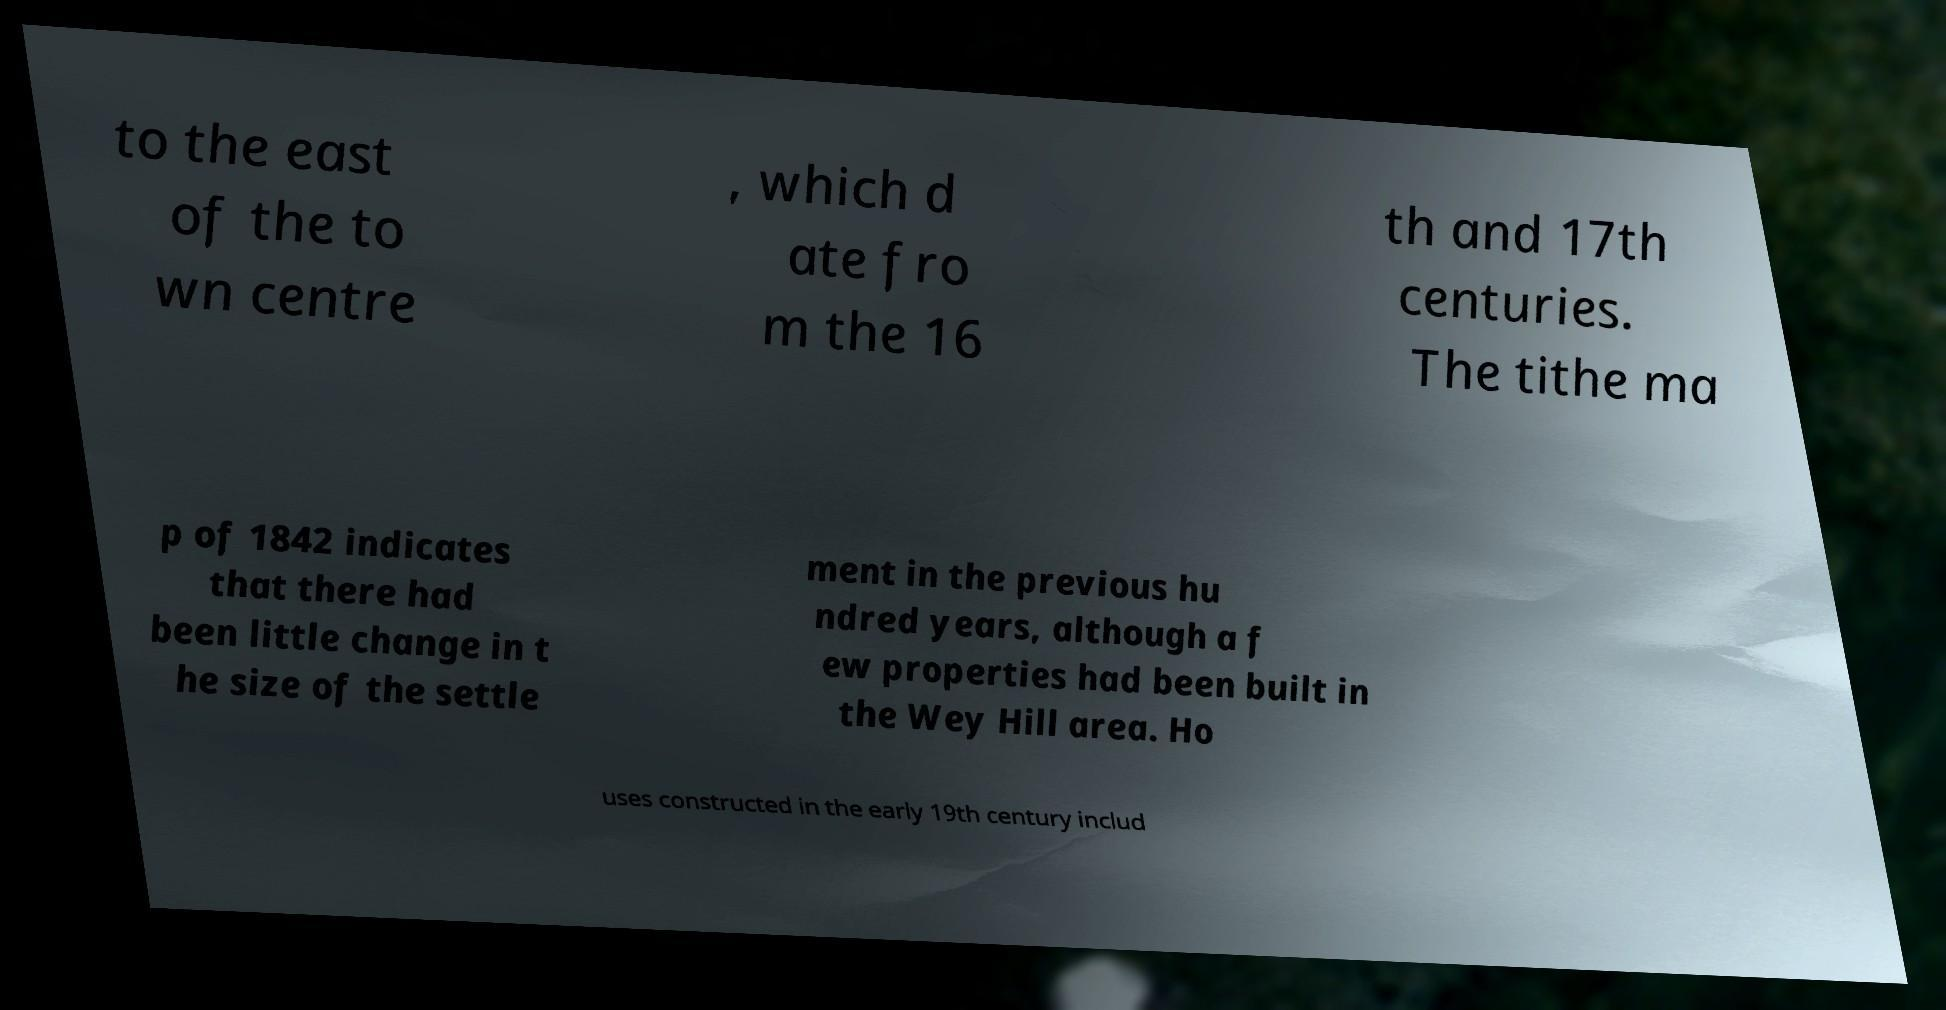For documentation purposes, I need the text within this image transcribed. Could you provide that? to the east of the to wn centre , which d ate fro m the 16 th and 17th centuries. The tithe ma p of 1842 indicates that there had been little change in t he size of the settle ment in the previous hu ndred years, although a f ew properties had been built in the Wey Hill area. Ho uses constructed in the early 19th century includ 